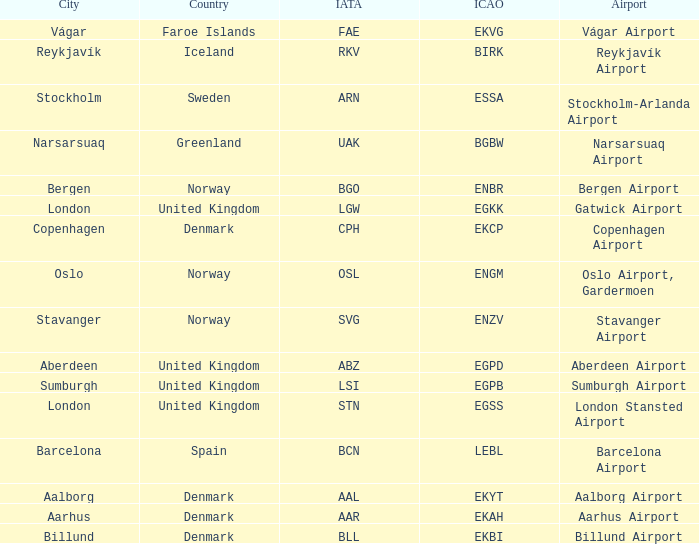What country has an ICAO of ENZV? Norway. 